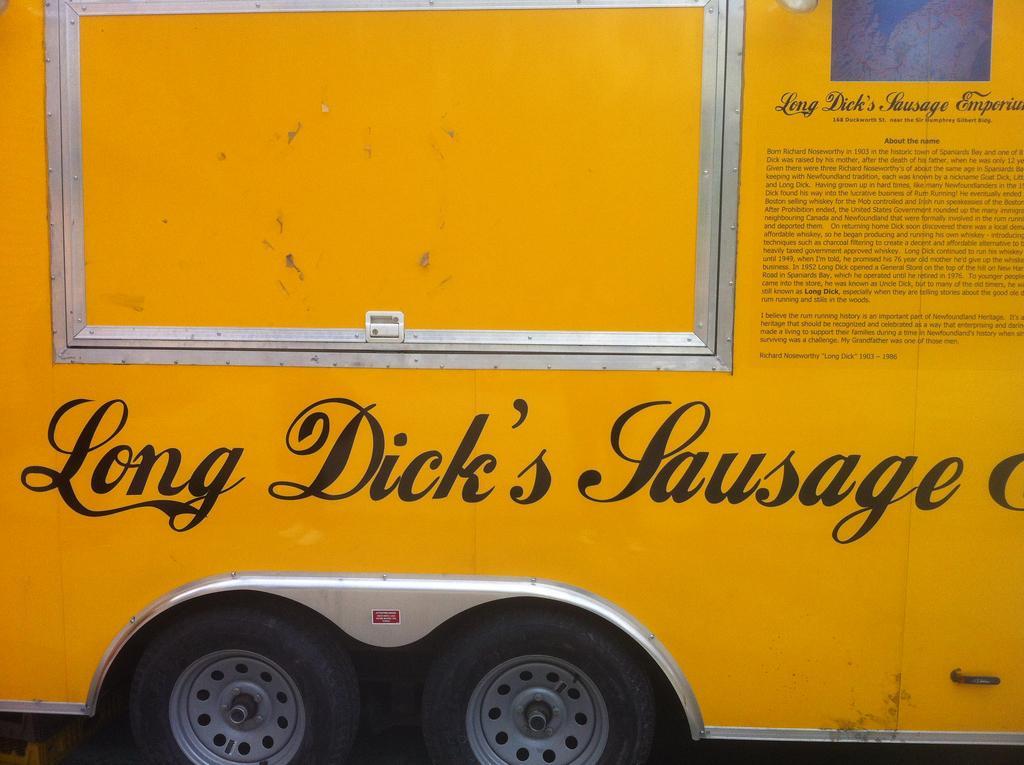Could you give a brief overview of what you see in this image? In the image there is a vehicle with wheels. And on the vehicle is some text on it. 